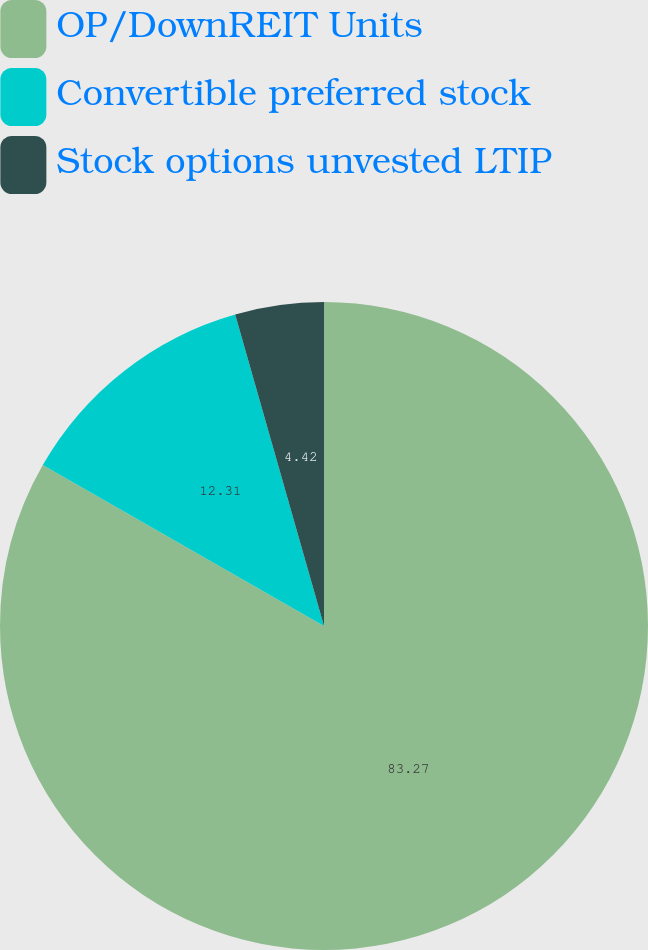Convert chart to OTSL. <chart><loc_0><loc_0><loc_500><loc_500><pie_chart><fcel>OP/DownREIT Units<fcel>Convertible preferred stock<fcel>Stock options unvested LTIP<nl><fcel>83.27%<fcel>12.31%<fcel>4.42%<nl></chart> 